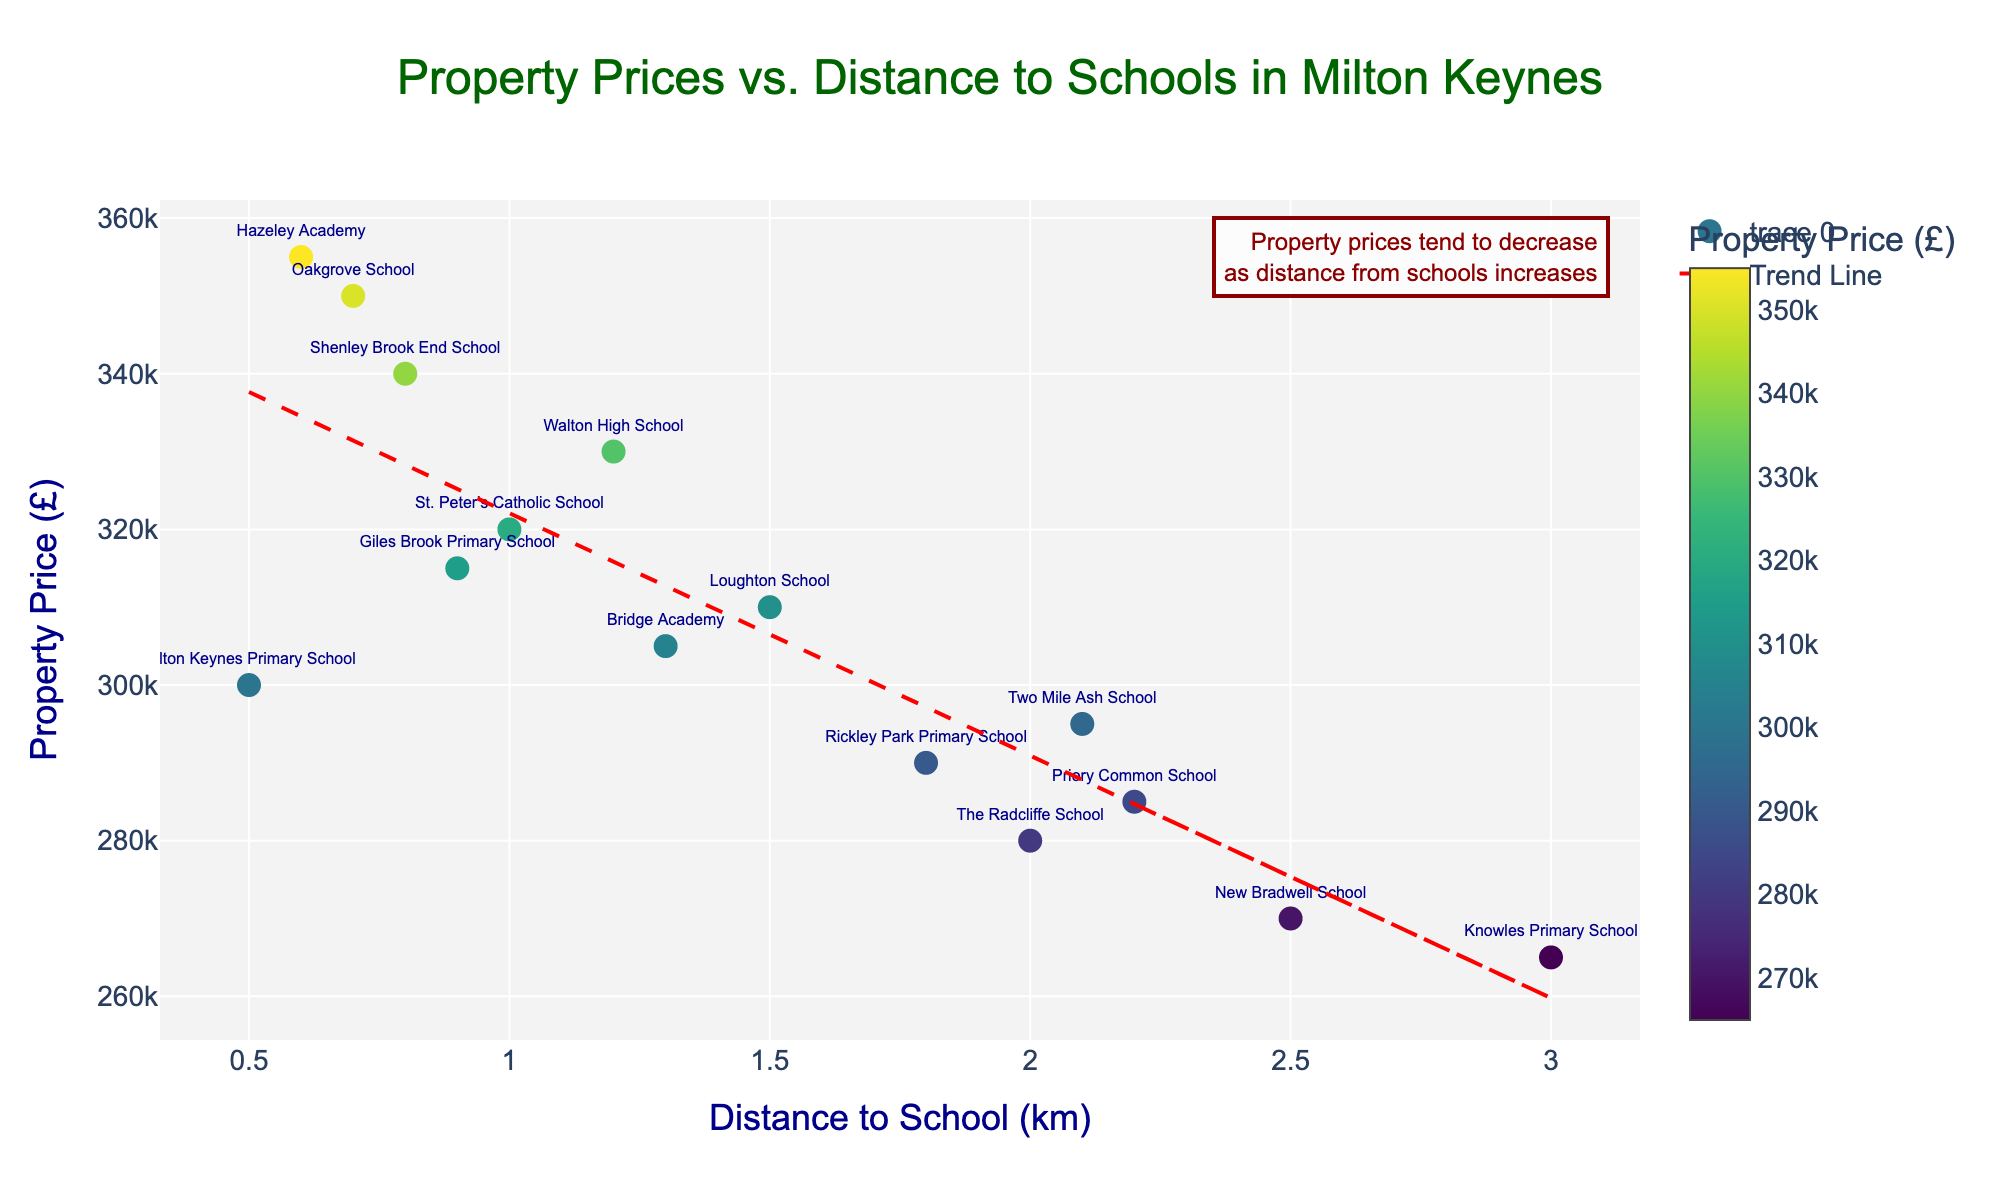How many data points are shown on the scatter plot? To count the number of data points in the scatter plot, look for each marker representing a school. There are 15 schools listed in the dataset, so there should be 15 markers.
Answer: 15 What is the title of the scatter plot? The title is displayed at the top of the scatter plot, often in a larger and different colored font.
Answer: Property Prices vs. Distance to Schools in Milton Keynes What is the property price of the closest and farthest schools from their respective markers? The closest school marker is for Milton Keynes Primary School at 0.5 km with a price of £300,000, and the farthest is Knowles Primary School at 3.0 km with a price of £265,000.
Answer: £300,000 and £265,000 Which school has the highest property price associated with it? By looking at the hover information or the color intensity of the markers, Hazeley Academy at 0.6 km with £355,000 is the highest.
Answer: Hazeley Academy What is the general trend shown by the scatter plot and the trend line? The red dashed trend line shows that as the distance to school increases, property prices tend to decrease.
Answer: Prices decrease with distance How many schools are within 1 km distance? To answer this, check how many markers are at or below the 1 km mark on the x-axis.
Answer: 4 Compare the property prices of Oakgrove School and Two Mile Ash School. Which one is higher? Oakgrove School has a property price of £350,000, and Two Mile Ash School has a price of £295,000. Comparing these, Oakgrove School has a higher property price.
Answer: Oakgrove School What is the average property price for schools within 2 km distance? Calculate the average by summing the property prices of schools within 2 km (300000, 320000, 350000, 310000, 330000, 340000, 290000, 315000, 355000) and dividing by the number of schools (9). The sum is 3210000, so 3210000/9 = 356666.67.
Answer: £356,666.67 What is the difference in property price between Walton High School and Loughton School? Walton High School's price is £330,000 and Loughton School's price is £310,000. The difference is £330,000 - £310,000 = £20,000.
Answer: £20,000 Is there a school with a property price lower than £280,000 within 2 km? Check the property prices of each school within 2 km. Except for The Radcliffe School at £280,000, no other school within 2 km has a price lower than £280,000.
Answer: No 